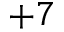Convert formula to latex. <formula><loc_0><loc_0><loc_500><loc_500>+ 7</formula> 